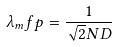Convert formula to latex. <formula><loc_0><loc_0><loc_500><loc_500>\lambda _ { m } f p = \frac { 1 } { \sqrt { 2 } N D }</formula> 